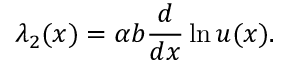<formula> <loc_0><loc_0><loc_500><loc_500>\lambda _ { 2 } ( x ) = \alpha b { \frac { d } { d x } } \ln u ( x ) .</formula> 